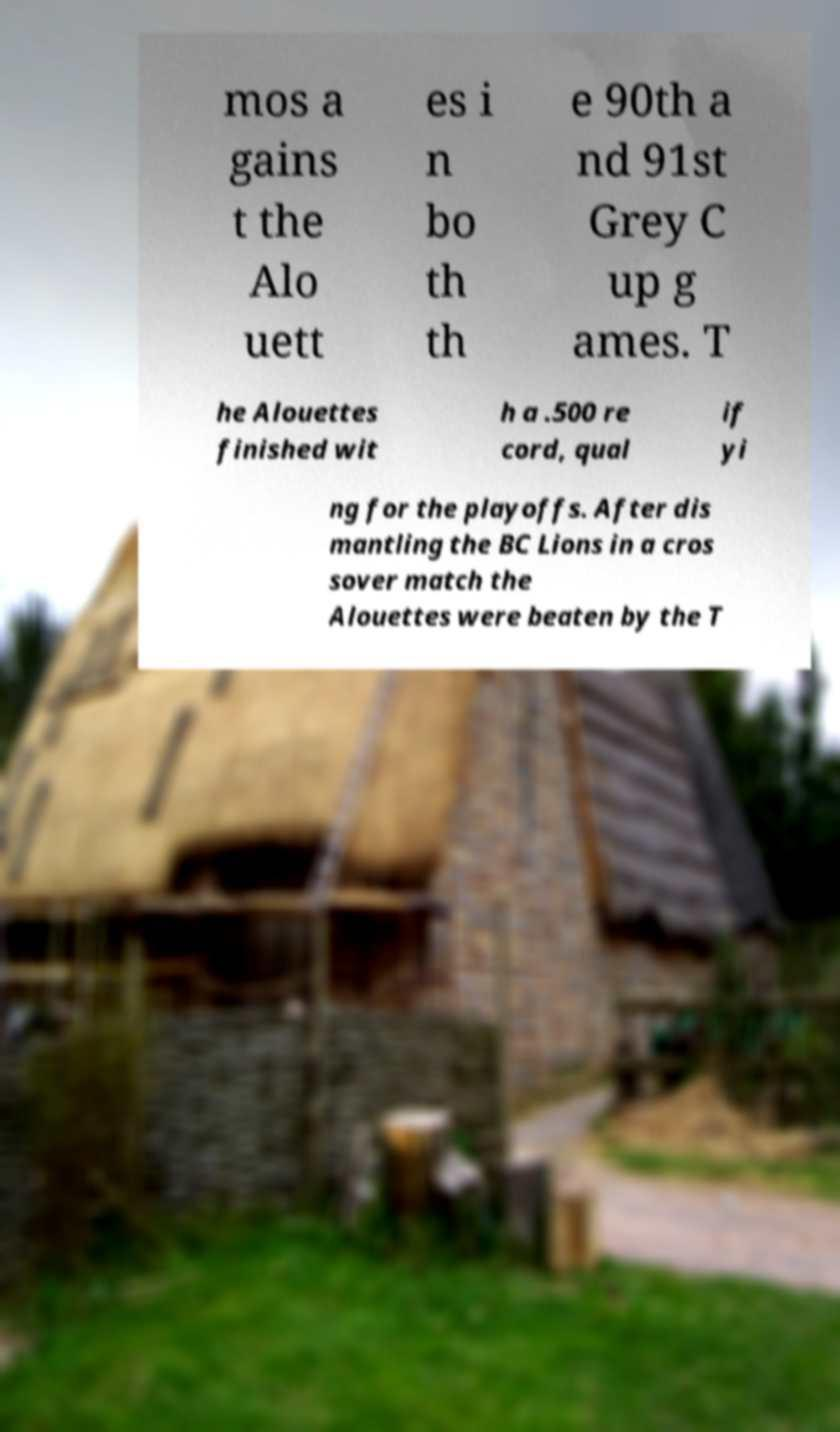Can you read and provide the text displayed in the image?This photo seems to have some interesting text. Can you extract and type it out for me? mos a gains t the Alo uett es i n bo th th e 90th a nd 91st Grey C up g ames. T he Alouettes finished wit h a .500 re cord, qual if yi ng for the playoffs. After dis mantling the BC Lions in a cros sover match the Alouettes were beaten by the T 